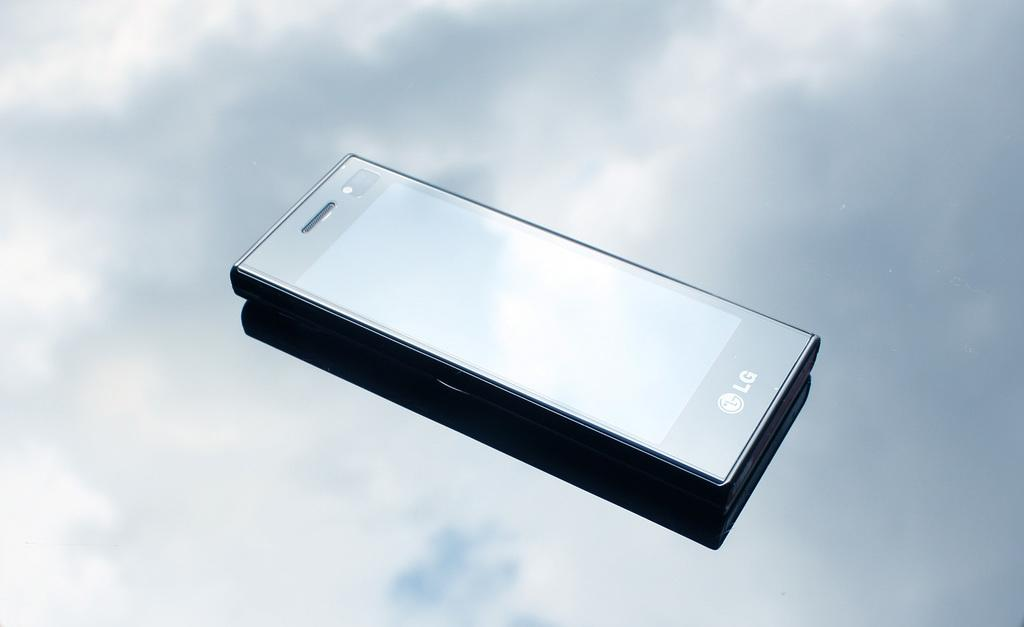<image>
Describe the image concisely. a phone with the word LG on it 